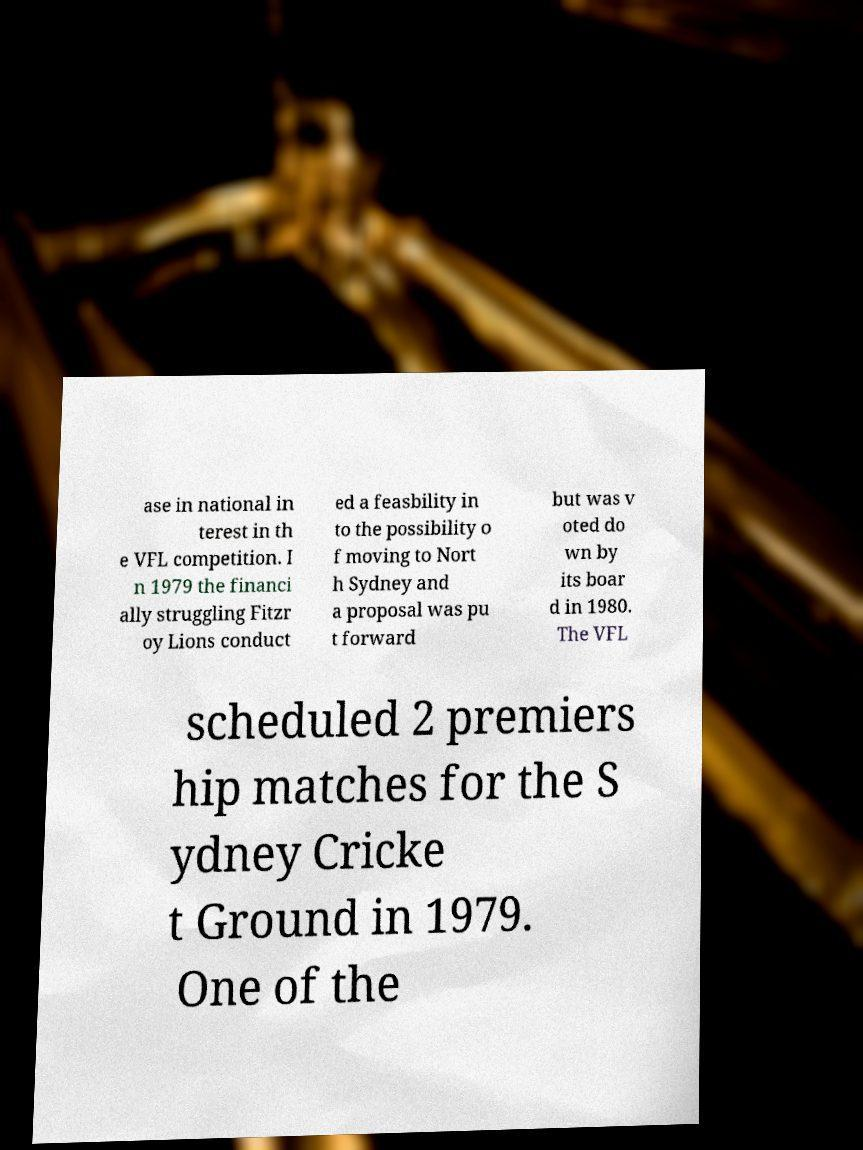For documentation purposes, I need the text within this image transcribed. Could you provide that? ase in national in terest in th e VFL competition. I n 1979 the financi ally struggling Fitzr oy Lions conduct ed a feasbility in to the possibility o f moving to Nort h Sydney and a proposal was pu t forward but was v oted do wn by its boar d in 1980. The VFL scheduled 2 premiers hip matches for the S ydney Cricke t Ground in 1979. One of the 